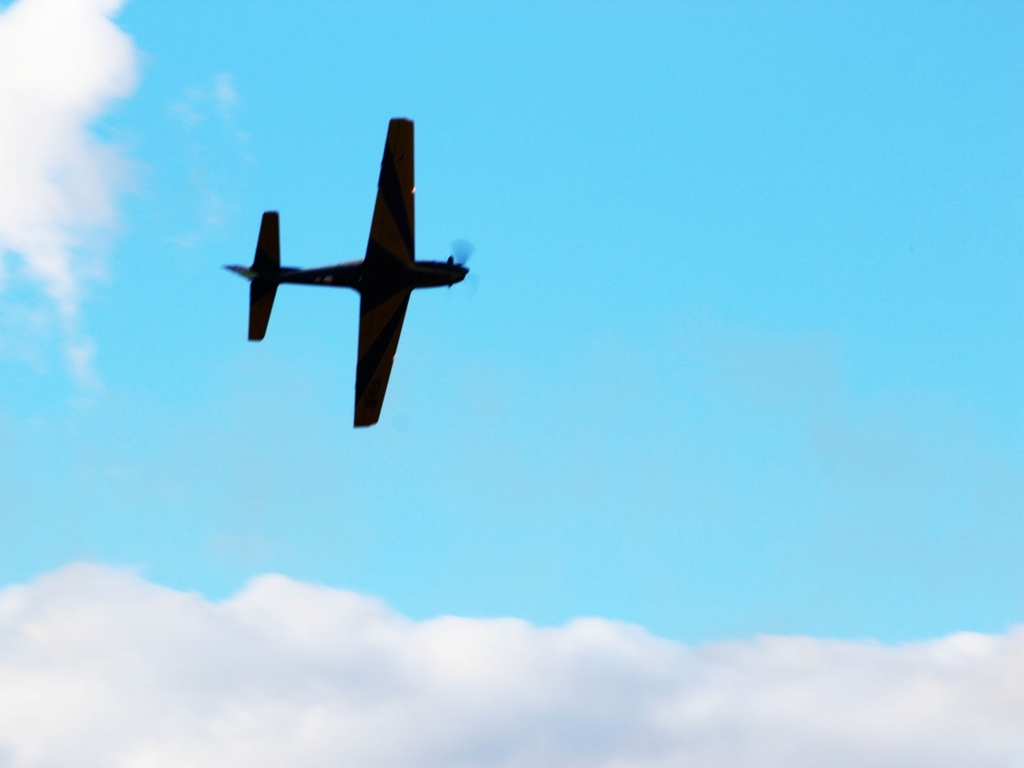Can you describe the weather conditions and how they might affect the flight experience in the image? The weather looks clear with some scattered clouds, suggesting favorable conditions for flying. Such weather generally allows for smooth flying experiences with good visibility for the pilot. However, cloud patterns could indicate variations in wind speed and direction at different altitudes which pilots must consider. What emotions might someone feel when watching this airplane in the sky? Observers might experience a sense of freedom and tranquility, watching the airplane glide across the open sky. It could also evoke feelings of wanderlust or curiosity about aviation and travel. For some, it could be a reminder of the marvel of human ingenuity in achieving flight. 